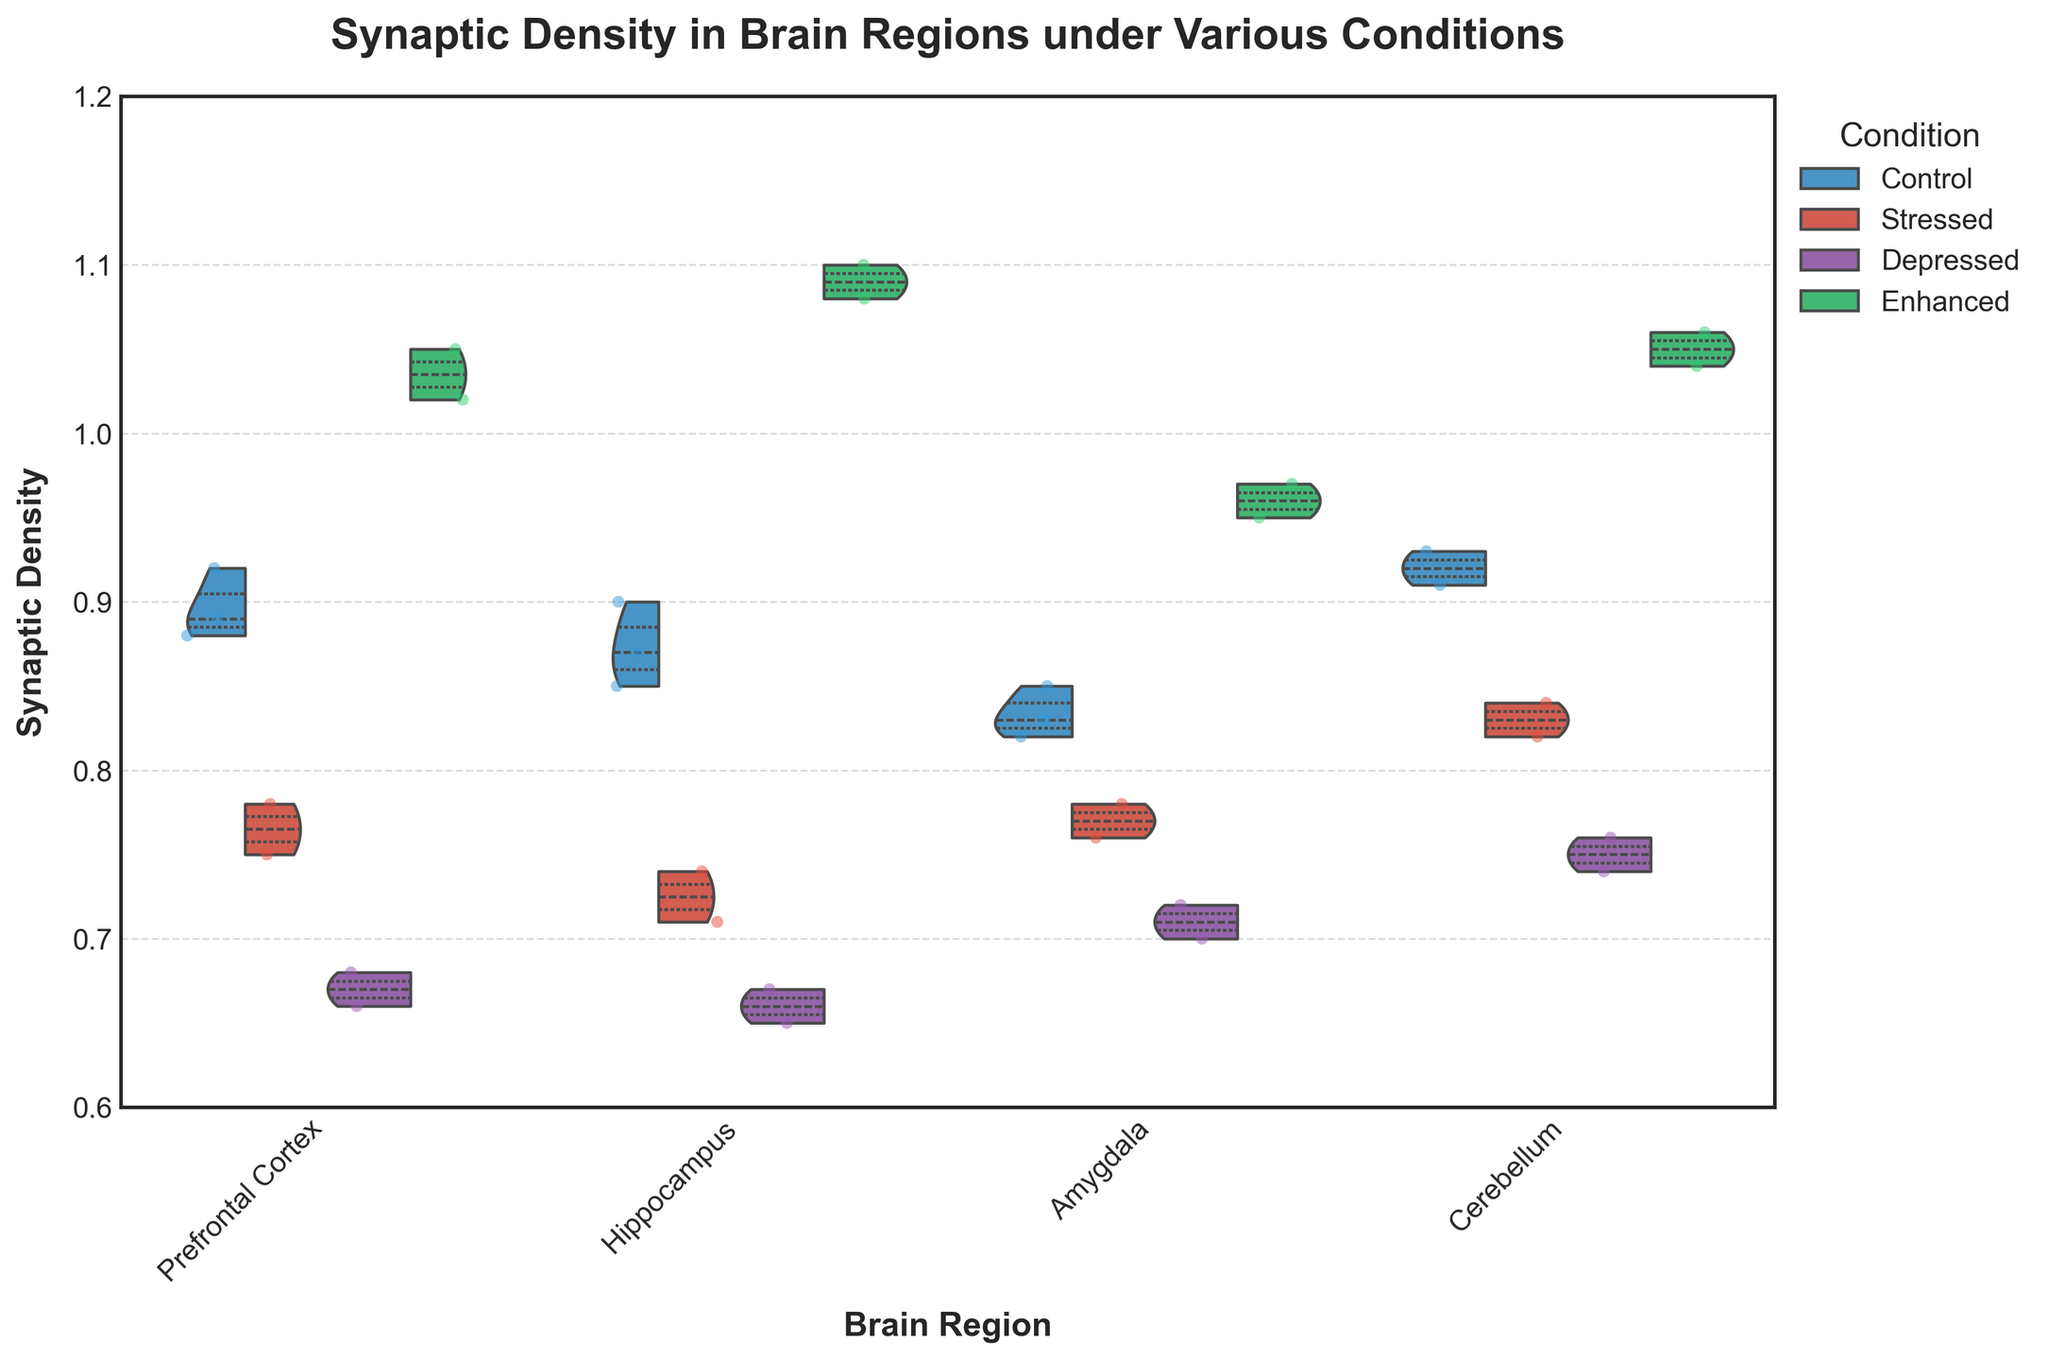How many experimental conditions are displayed in the figure? By looking at the legend, there are four different experimental conditions shown: Control, Stressed, Depressed, and Enhanced.
Answer: Four Which brain region appears to have the highest maximum synaptic density under the Enhanced condition? By comparing the upper violin plot edges, the Hippocampus has the highest maximum synaptic density under the Enhanced condition, reaching approximately 1.10.
Answer: Hippocampus What is the range of synaptic density values for the Prefrontal Cortex under the Depressed condition? The violin plot for the Prefrontal Cortex under the Depressed condition ranges from approximately 0.66 to 0.68, as indicated by the spread of the jittered points.
Answer: 0.66 to 0.68 Which region exhibits the lowest minimum synaptic density under the Stressed condition? The violin plot for the Hippocampus under the Stressed condition shows the lowest minimum synaptic density, which is around 0.71.
Answer: Hippocampus How does the median synaptic density in the Control condition compare between the Amygdala and the Cerebellum? By looking at the inner quartile line in the violin plots, the median synaptic density in the Control condition for the Amygdala is approximately 0.83, while for the Cerebellum it is approximately 0.92, making the Cerebellum higher.
Answer: Cerebellum is higher Which experimental condition shows the highest variability in synaptic density within the Prefrontal Cortex? The width of the violin plot represents variability. The Enhanced condition in the Prefrontal Cortex shows the highest variability as it spans the widest range compared to the other conditions.
Answer: Enhanced Are there any overlapping regions of synaptic density between the Control and Stressed conditions in the Hippocampus? The two halves of the split violin plot for Control and Stressed conditions in the Hippocampus overlap between approximately 0.71 and 0.74.
Answer: Yes What's the cumulative synaptic density for the three data points plotted for the Control condition in the Amygdala? The synaptic density values for the Control condition in the Amygdala are 0.82, 0.85, and 0.83. Summing these values gives: 0.82 + 0.85 + 0.83 = 2.50.
Answer: 2.50 How does the spread of the synaptic density distributions for the Control and Depressed conditions compare in the Cerebellum? The spread is determined by the width of the violin plots. The Control condition in the Cerebellum is spread between approximately 0.91 and 0.93, while the Depressed condition is spread between around 0.74 and 0.76, making the Depressed condition slightly less spread.
Answer: The Control condition is slightly wider 